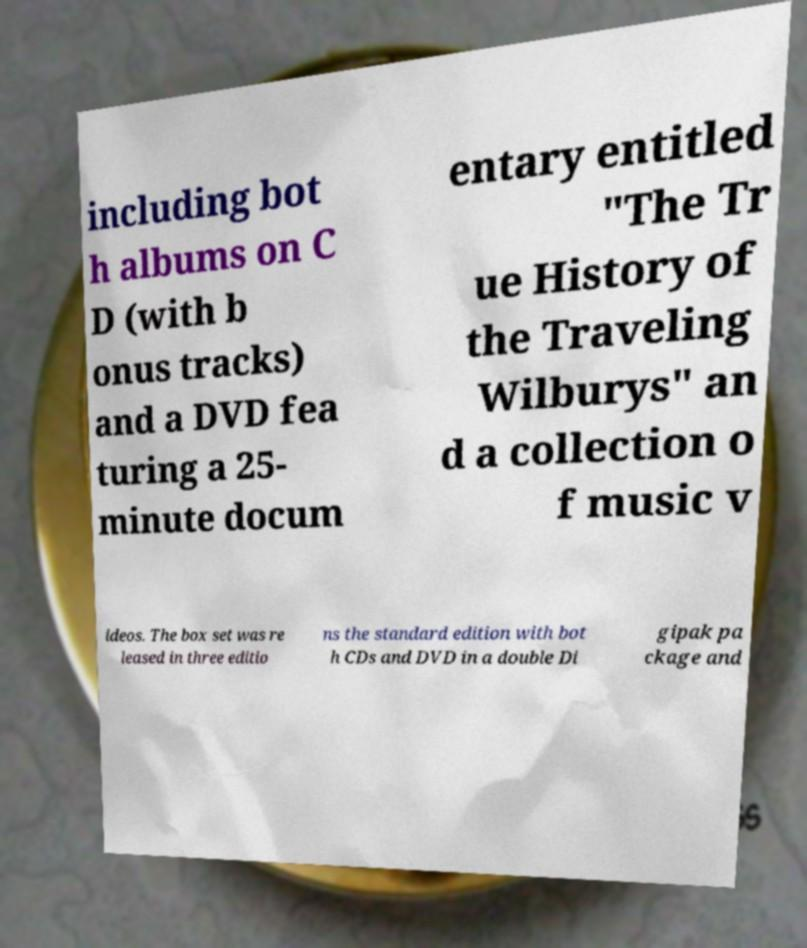Could you assist in decoding the text presented in this image and type it out clearly? including bot h albums on C D (with b onus tracks) and a DVD fea turing a 25- minute docum entary entitled "The Tr ue History of the Traveling Wilburys" an d a collection o f music v ideos. The box set was re leased in three editio ns the standard edition with bot h CDs and DVD in a double Di gipak pa ckage and 